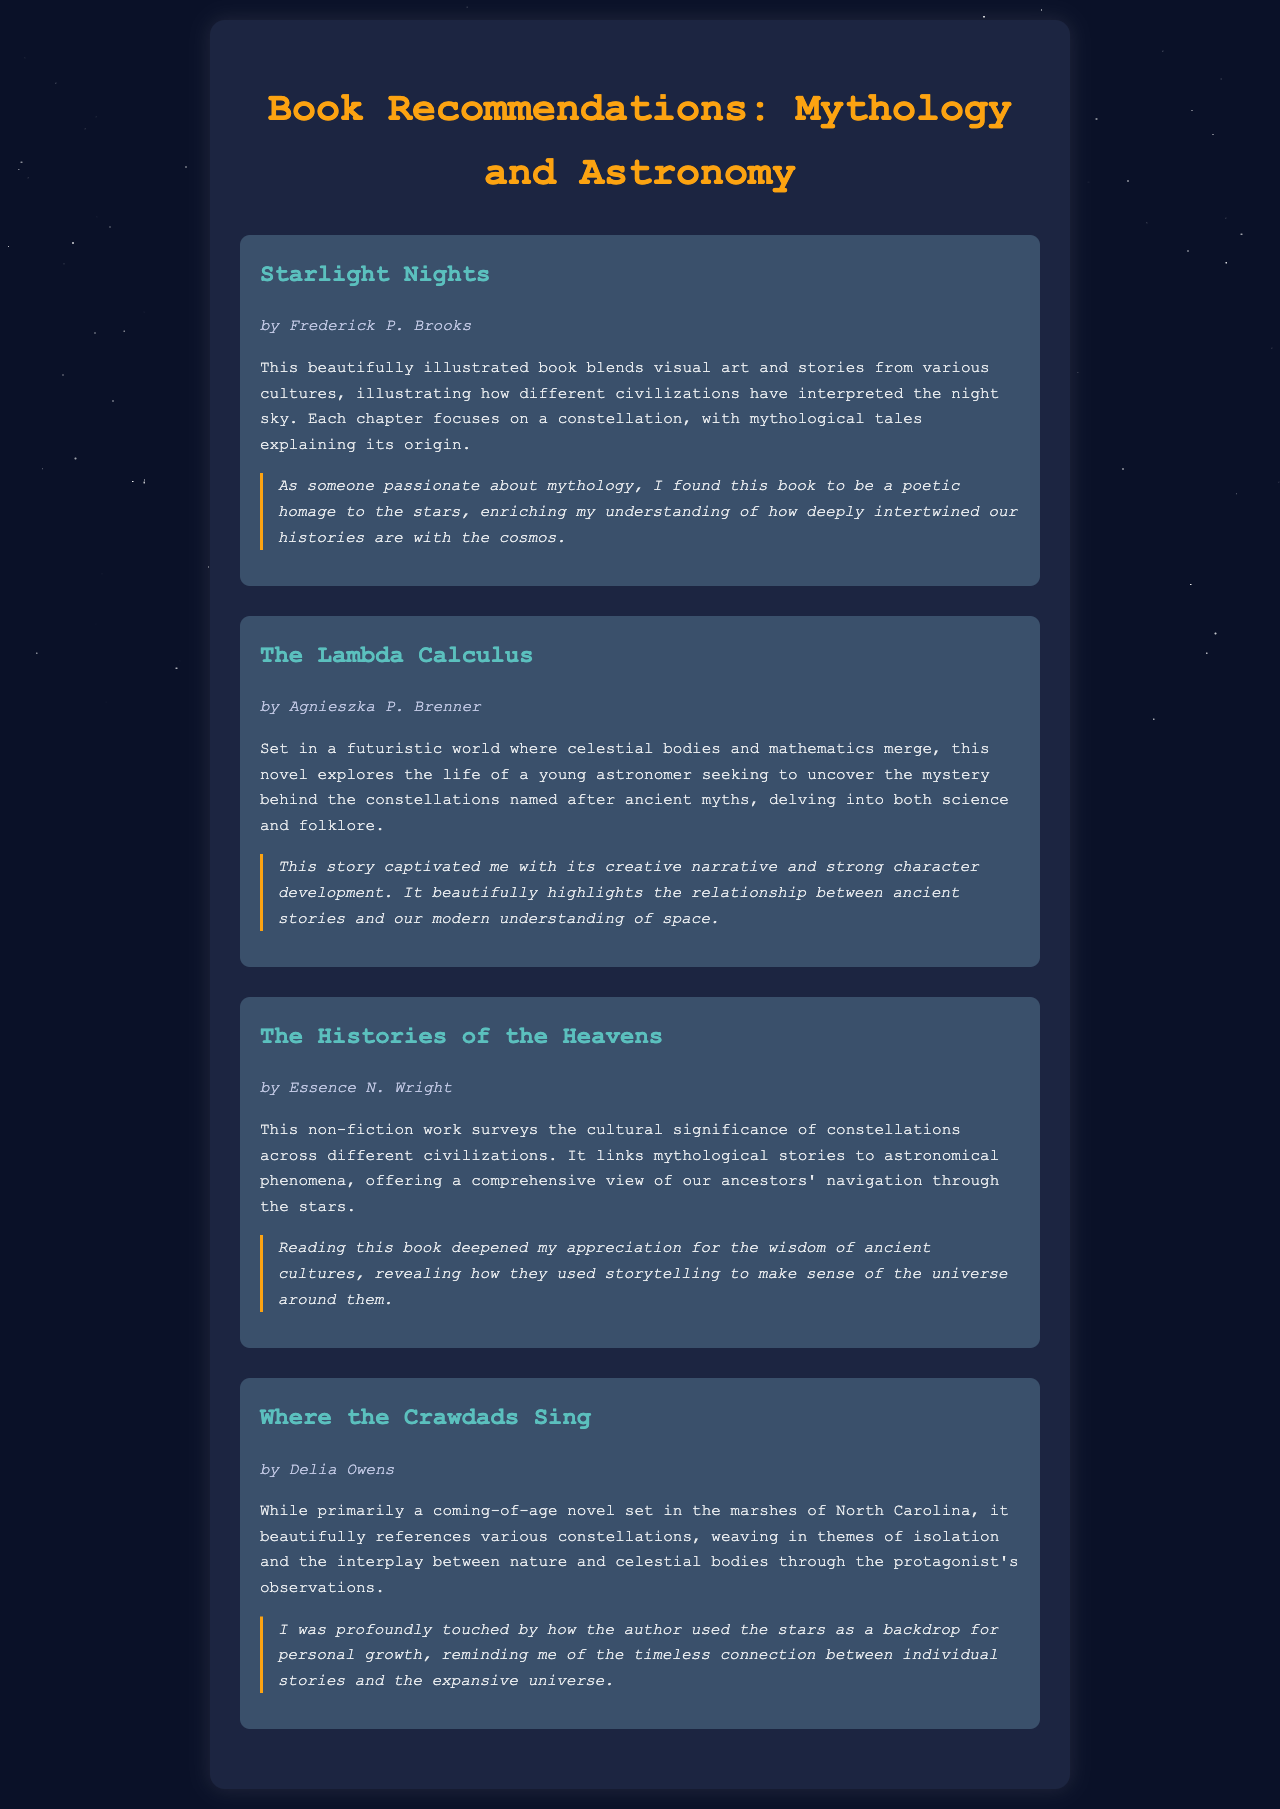What is the title of the first book? The title of the first book listed in the document is "Starlight Nights."
Answer: Starlight Nights Who is the author of "The Lambda Calculus"? The author of "The Lambda Calculus" is Agnieszka P. Brenner.
Answer: Agnieszka P. Brenner How many books are recommended in the document? The document lists four books as recommendations.
Answer: Four What theme does "Where the Crawdads Sing" primarily explore? "Where the Crawdads Sing" primarily explores coming-of-age and isolation themes interwoven with celestial references.
Answer: Coming-of-age and isolation Which book discusses the cultural significance of constellations? "The Histories of the Heavens" discusses the cultural significance of constellations.
Answer: The Histories of the Heavens What is the genre of "Starlight Nights"? "Starlight Nights" is a beautifully illustrated book blending visual art and mythology stories.
Answer: Illustrated mythology book In what style is the document presented? The document is presented in an HTML format with styling for aesthetics.
Answer: HTML format What is a key insight shared about "Starlight Nights"? A key insight shared about "Starlight Nights" is that it enriches understanding of the intertwining of histories with the cosmos.
Answer: Intertwining of histories with the cosmos 